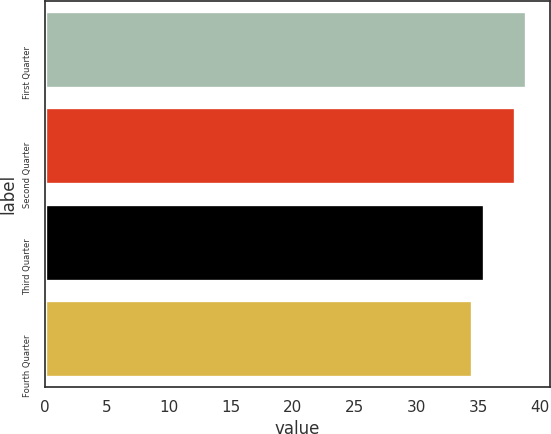Convert chart. <chart><loc_0><loc_0><loc_500><loc_500><bar_chart><fcel>First Quarter<fcel>Second Quarter<fcel>Third Quarter<fcel>Fourth Quarter<nl><fcel>38.84<fcel>37.96<fcel>35.48<fcel>34.53<nl></chart> 